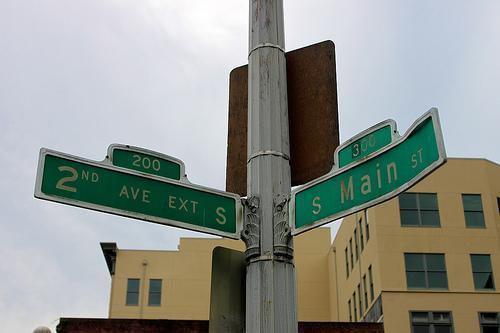How many street signs are there?
Give a very brief answer. 2. 